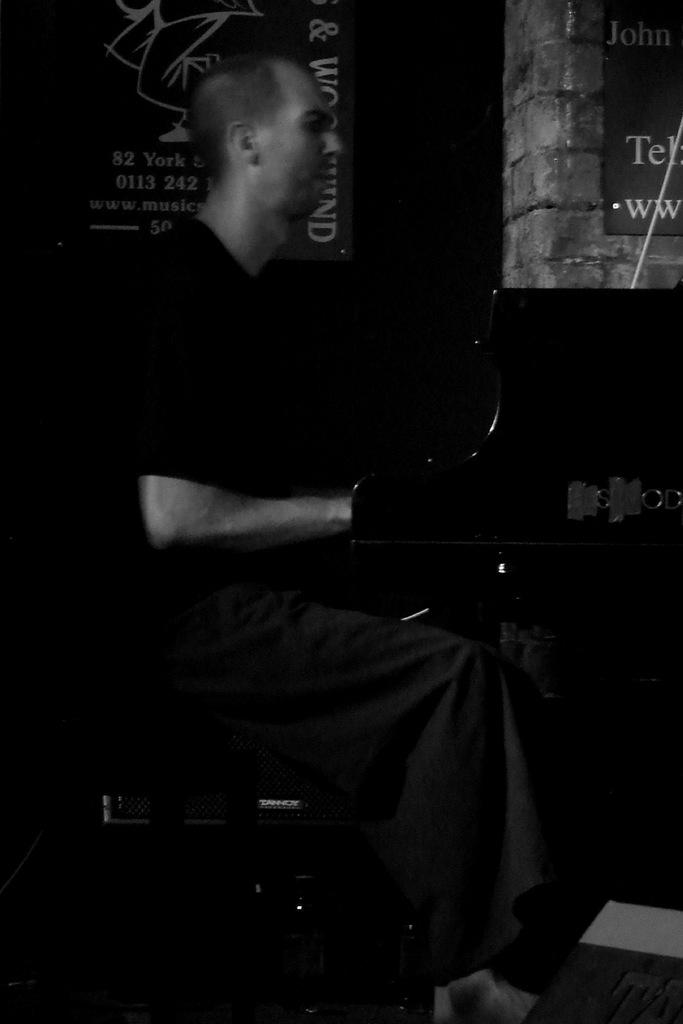What is the overall lighting condition in the image? The image is dark. What is the man in the image doing? The man is sitting in the image. What can be seen on the wall in the background of the image? There are boards on the wall in the background of the image. What type of shoe is the man wearing in the image? There is no shoe visible in the image, as the man is sitting and only his upper body is shown. What is the man spreading on the bread in the image? There is no bread or butter present in the image; it only features a man sitting with boards on the wall in the background. 